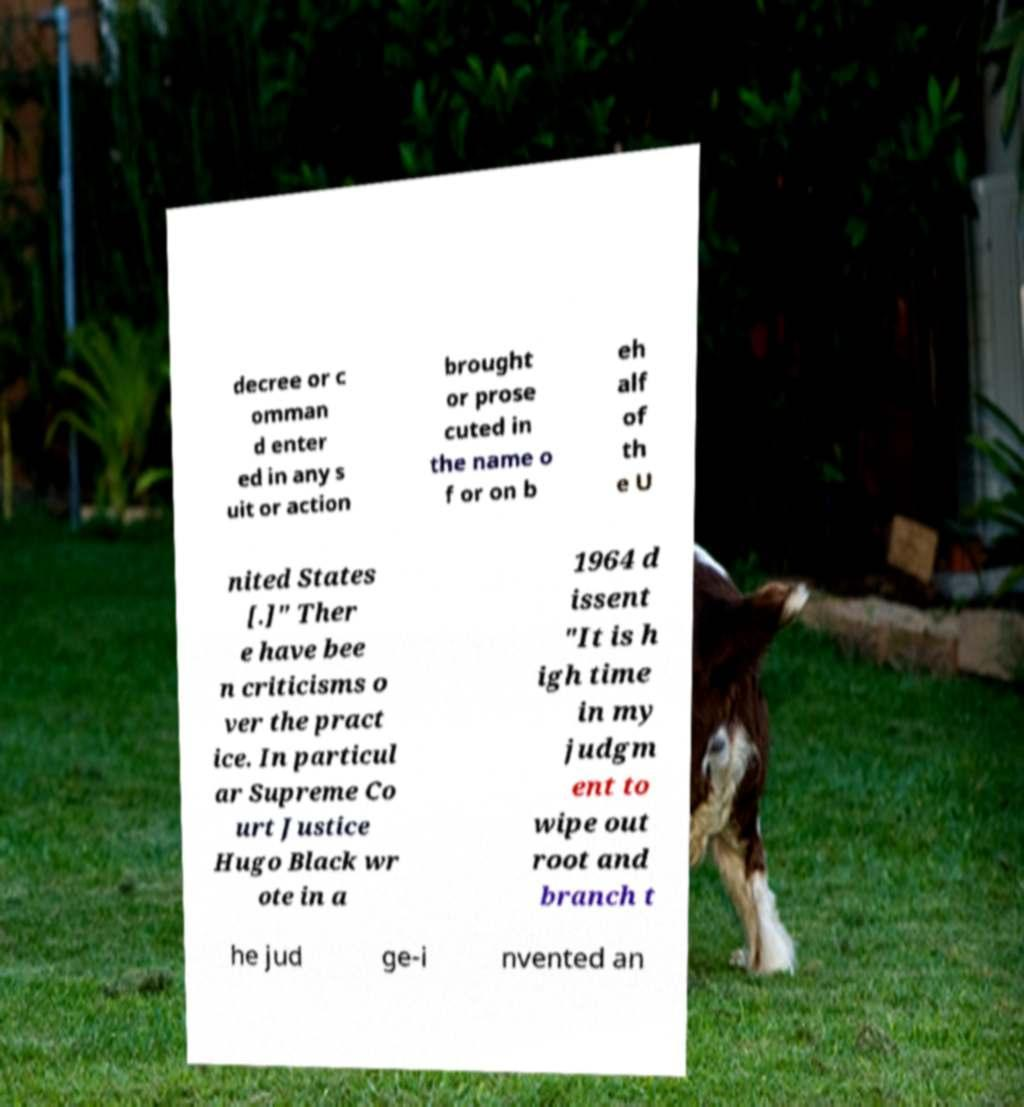There's text embedded in this image that I need extracted. Can you transcribe it verbatim? decree or c omman d enter ed in any s uit or action brought or prose cuted in the name o f or on b eh alf of th e U nited States [.]" Ther e have bee n criticisms o ver the pract ice. In particul ar Supreme Co urt Justice Hugo Black wr ote in a 1964 d issent "It is h igh time in my judgm ent to wipe out root and branch t he jud ge-i nvented an 